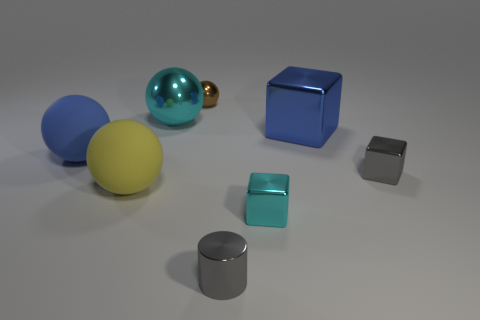What is the color of the metallic cube that is the same size as the yellow object?
Offer a terse response. Blue. Do the yellow rubber sphere and the blue rubber ball have the same size?
Ensure brevity in your answer.  Yes. What is the size of the thing that is on the left side of the cyan ball and in front of the small gray cube?
Offer a terse response. Large. How many metallic things are cylinders or big balls?
Make the answer very short. 2. Are there more tiny metal spheres that are behind the yellow sphere than large yellow shiny cylinders?
Give a very brief answer. Yes. What is the big blue thing to the left of the cylinder made of?
Your answer should be compact. Rubber. What number of tiny cylinders are made of the same material as the tiny brown sphere?
Provide a short and direct response. 1. There is a metallic thing that is both left of the gray cylinder and in front of the brown shiny thing; what is its shape?
Your answer should be compact. Sphere. How many objects are small shiny things behind the large cyan shiny thing or tiny things in front of the large cyan shiny object?
Keep it short and to the point. 4. Is the number of big cyan balls to the right of the small brown metal thing the same as the number of blue shiny cubes that are behind the big yellow thing?
Ensure brevity in your answer.  No. 